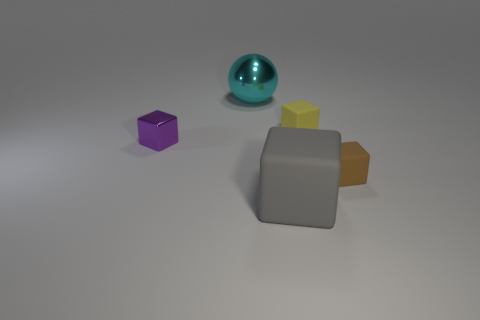Add 1 small red metallic cylinders. How many objects exist? 6 Subtract all blocks. How many objects are left? 1 Add 2 large purple shiny cubes. How many large purple shiny cubes exist? 2 Subtract 1 purple cubes. How many objects are left? 4 Subtract all small yellow rubber things. Subtract all matte objects. How many objects are left? 1 Add 3 tiny brown blocks. How many tiny brown blocks are left? 4 